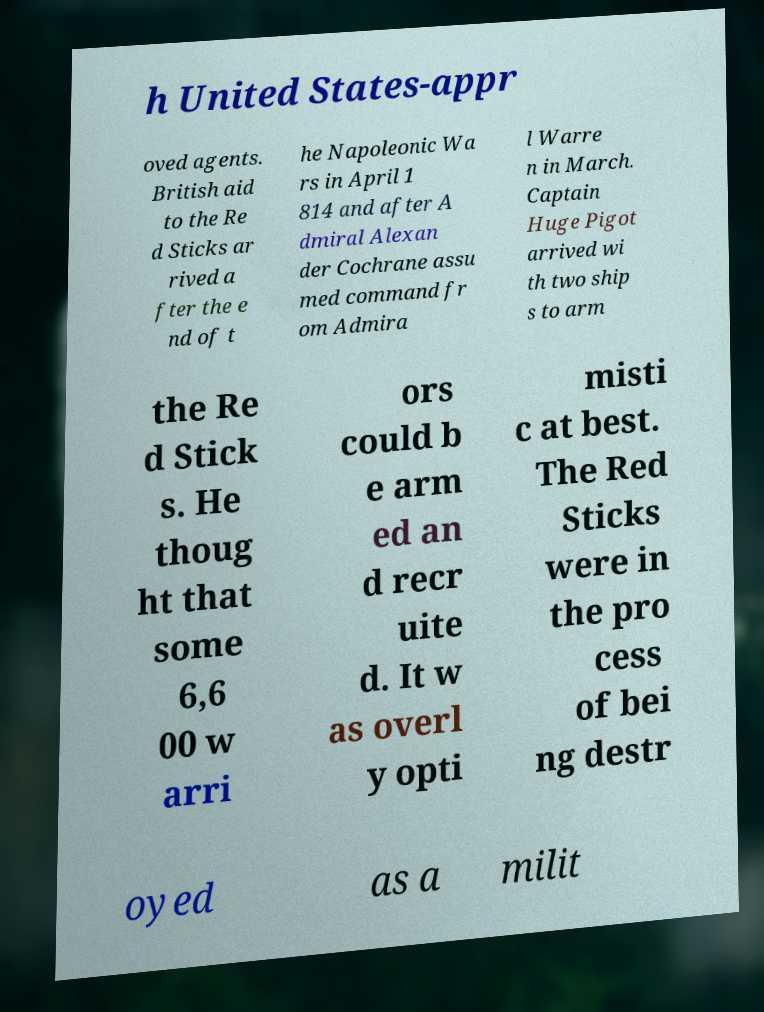There's text embedded in this image that I need extracted. Can you transcribe it verbatim? h United States-appr oved agents. British aid to the Re d Sticks ar rived a fter the e nd of t he Napoleonic Wa rs in April 1 814 and after A dmiral Alexan der Cochrane assu med command fr om Admira l Warre n in March. Captain Huge Pigot arrived wi th two ship s to arm the Re d Stick s. He thoug ht that some 6,6 00 w arri ors could b e arm ed an d recr uite d. It w as overl y opti misti c at best. The Red Sticks were in the pro cess of bei ng destr oyed as a milit 